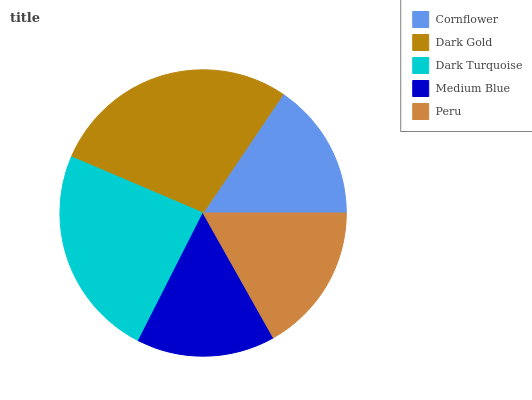Is Cornflower the minimum?
Answer yes or no. Yes. Is Dark Gold the maximum?
Answer yes or no. Yes. Is Dark Turquoise the minimum?
Answer yes or no. No. Is Dark Turquoise the maximum?
Answer yes or no. No. Is Dark Gold greater than Dark Turquoise?
Answer yes or no. Yes. Is Dark Turquoise less than Dark Gold?
Answer yes or no. Yes. Is Dark Turquoise greater than Dark Gold?
Answer yes or no. No. Is Dark Gold less than Dark Turquoise?
Answer yes or no. No. Is Peru the high median?
Answer yes or no. Yes. Is Peru the low median?
Answer yes or no. Yes. Is Dark Gold the high median?
Answer yes or no. No. Is Cornflower the low median?
Answer yes or no. No. 